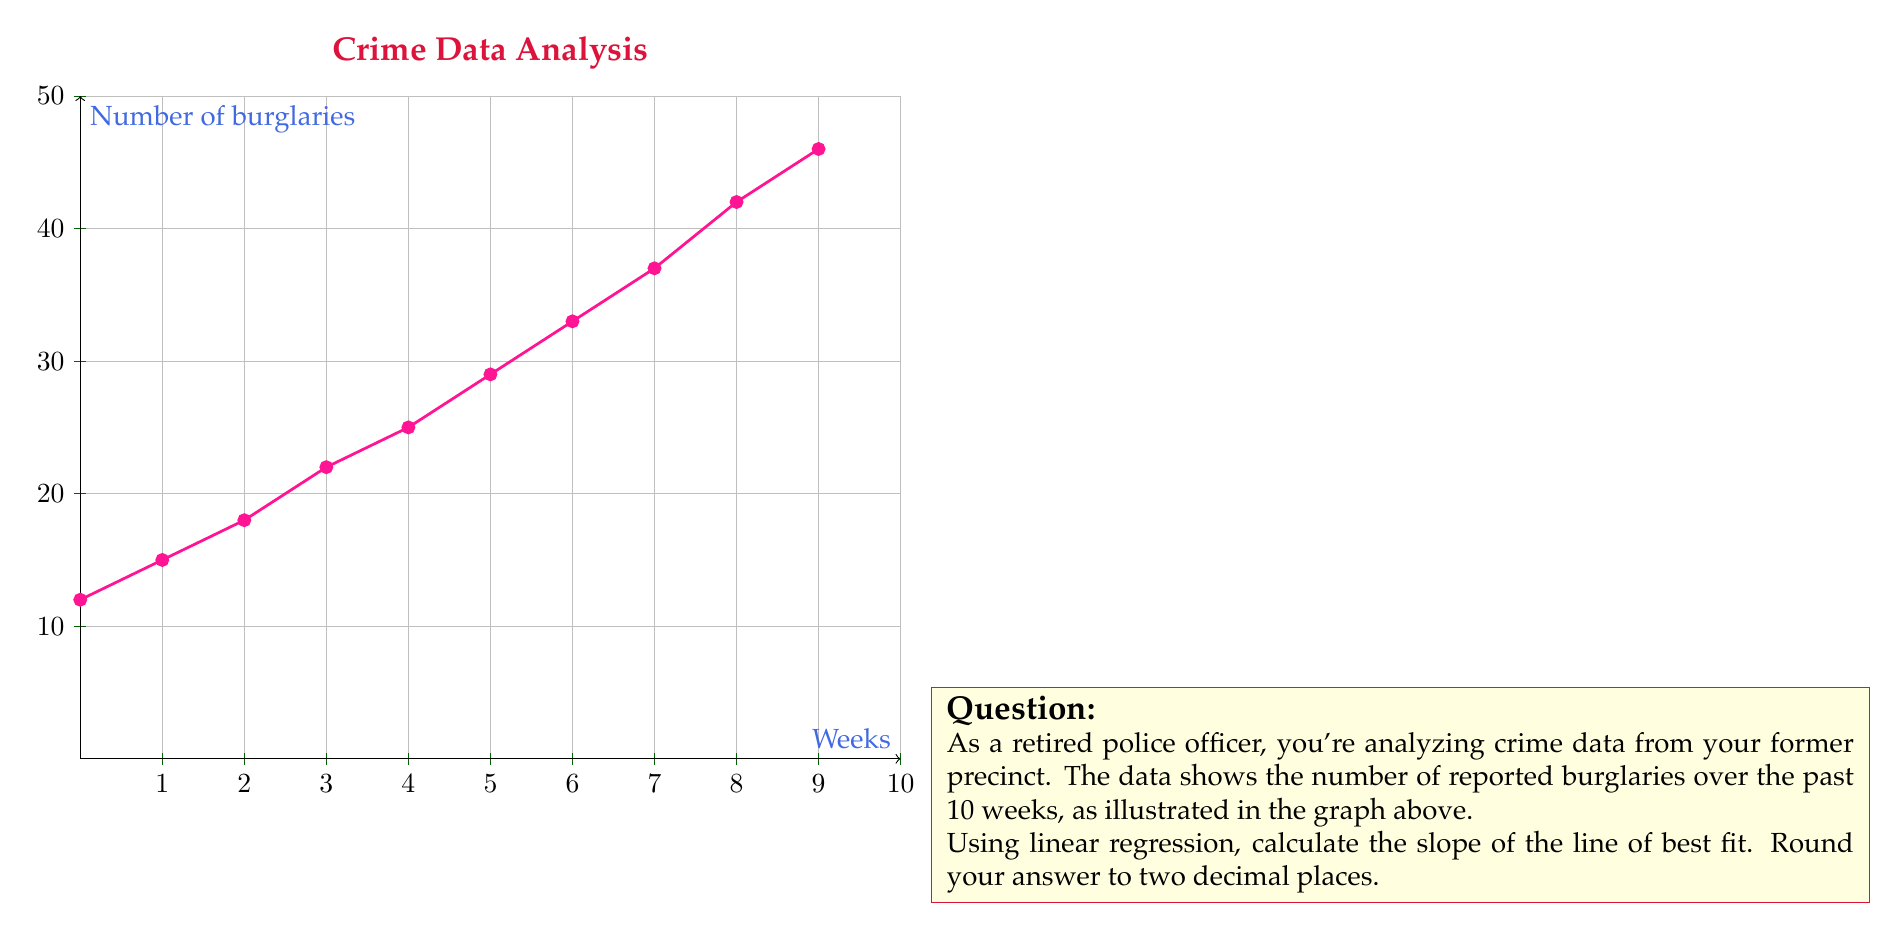Can you solve this math problem? To find the slope of the line of best fit using linear regression, we'll use the formula:

$$ m = \frac{n\sum xy - \sum x \sum y}{n\sum x^2 - (\sum x)^2} $$

Where:
$n$ = number of data points
$x$ = week number (1 to 10)
$y$ = number of burglaries

Let's calculate each component:

1) $n = 10$

2) $\sum x = 1 + 2 + 3 + ... + 10 = 55$

3) $\sum y = 12 + 15 + 18 + 22 + 25 + 29 + 33 + 37 + 42 + 46 = 279$

4) $\sum xy = (1 \times 12) + (2 \times 15) + ... + (10 \times 46) = 2111$

5) $\sum x^2 = 1^2 + 2^2 + ... + 10^2 = 385$

Now, let's substitute these values into the formula:

$$ m = \frac{10(2111) - 55(279)}{10(385) - 55^2} $$

$$ m = \frac{21110 - 15345}{3850 - 3025} $$

$$ m = \frac{5765}{825} $$

$$ m \approx 3.78787878788 $$

Rounding to two decimal places: $m \approx 3.79$
Answer: 3.79 